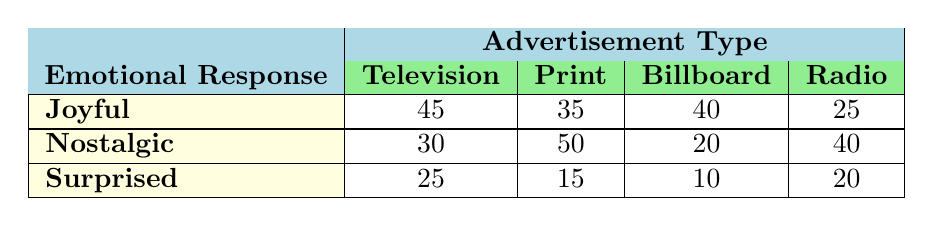What is the emotional response rating for Television Commercials categorized as Joyful? The table shows that the count for the emotional response "Joyful" under "Television" is 45.
Answer: 45 Which advertisement type has the highest count for the emotional response Nostalgic? In the table, the Print Advertisement has the highest count of 50 for the emotional response "Nostalgic."
Answer: Print Advertisement What is the total count of Joyful responses across all advertisement types? To find the total for "Joyful," sum the counts: 45 (Television) + 35 (Print) + 40 (Billboard) + 25 (Radio) = 145.
Answer: 145 How many more counts does the Television Commercial have for Joyful responses compared to Billboard responses? The count for Joyful in Television is 45, while in Billboard it's 40. The difference is 45 - 40 = 5.
Answer: 5 Is the emotional response count for Surprised higher in Radio advertisements than in Billboard advertisements? For Radio, the count is 20, and for Billboard, it's 10. Since 20 is greater than 10, the statement is true.
Answer: Yes What is the average count of the emotional response Nostalgic across all advertisement types? To calculate the average, sum the counts for Nostalgic: 30 (Television) + 50 (Print) + 20 (Billboard) + 40 (Radio) = 140. Then divide by the number of advertisement types (4): 140 / 4 = 35.
Answer: 35 Which emotional response received the least count in total across all advertisement types? For "Surprised," the counts are 25 (Television), 15 (Print), 10 (Billboard), and 20 (Radio). The total is 25 + 15 + 10 + 20 = 70, which is lower than for Joyful (145) or Nostalgic (140).
Answer: Surprised Does the data show that the sum of counts for Joyful and Surprised responses is the same for Print advertisements? The count for Joyful in Print is 35 and for Surprised is 15. Their sum is 35 + 15 = 50, while Nostalgic, for context, is 50 too. The statement is therefore false since the sums are the same but only when Joyful and Surprised are evaluated individually.
Answer: No Which advertisement type shows the greatest difference between Joyful and Surprised counts? Calculate the differences: Television (45 - 25 = 20), Print (35 - 15 = 20), Billboard (40 - 10 = 30), Radio (25 - 20 = 5). The greatest difference is 30 for Billboard.
Answer: Billboard 